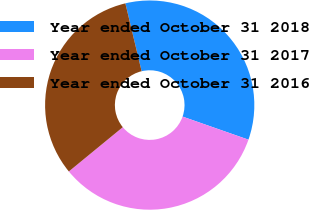Convert chart. <chart><loc_0><loc_0><loc_500><loc_500><pie_chart><fcel>Year ended October 31 2018<fcel>Year ended October 31 2017<fcel>Year ended October 31 2016<nl><fcel>34.1%<fcel>33.7%<fcel>32.2%<nl></chart> 